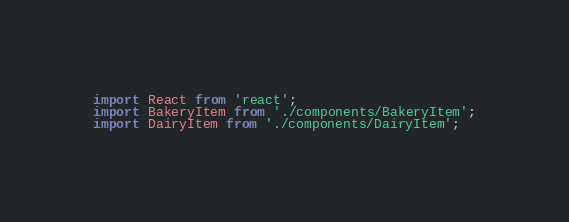<code> <loc_0><loc_0><loc_500><loc_500><_JavaScript_>import React from 'react';
import BakeryItem from './components/BakeryItem';
import DairyItem from './components/DairyItem';</code> 